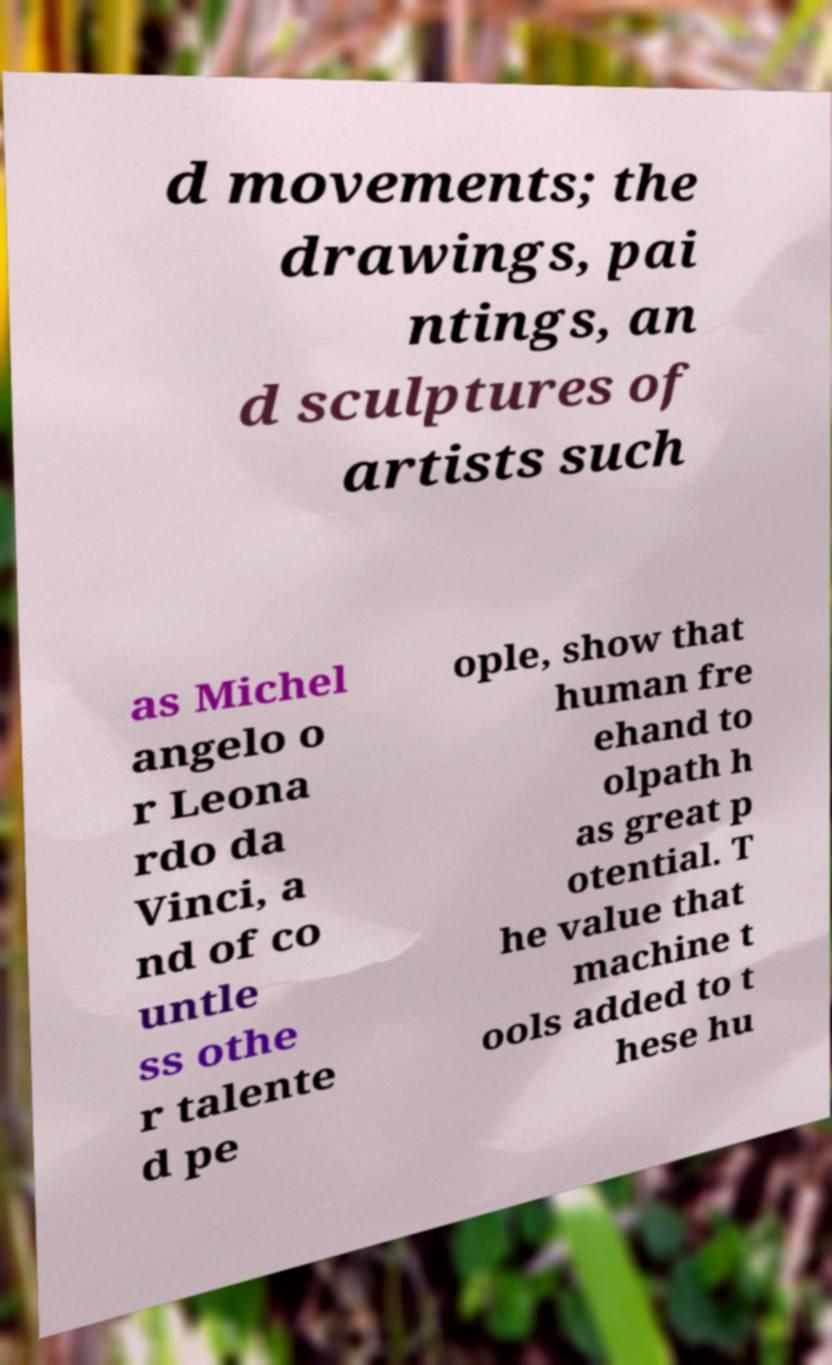For documentation purposes, I need the text within this image transcribed. Could you provide that? d movements; the drawings, pai ntings, an d sculptures of artists such as Michel angelo o r Leona rdo da Vinci, a nd of co untle ss othe r talente d pe ople, show that human fre ehand to olpath h as great p otential. T he value that machine t ools added to t hese hu 